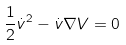<formula> <loc_0><loc_0><loc_500><loc_500>\frac { 1 } { 2 } \dot { v } ^ { 2 } - \dot { v } \nabla V = 0</formula> 